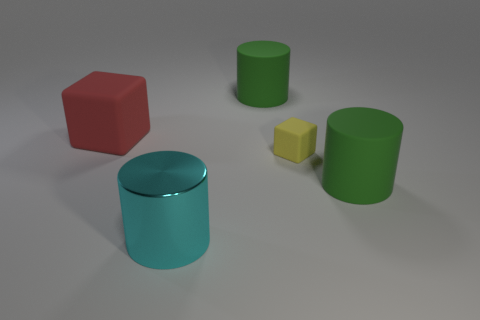Are there any other things that are the same size as the yellow matte thing?
Your answer should be compact. No. Is there any other thing that is the same material as the cyan object?
Give a very brief answer. No. There is a object that is both behind the cyan cylinder and in front of the tiny cube; how big is it?
Your answer should be compact. Large. What is the shape of the green matte thing that is on the right side of the small yellow thing?
Your response must be concise. Cylinder. Is the material of the red cube the same as the large green cylinder that is in front of the red rubber block?
Keep it short and to the point. Yes. Does the large cyan metal object have the same shape as the small yellow object?
Give a very brief answer. No. There is another object that is the same shape as the tiny object; what is it made of?
Provide a succinct answer. Rubber. The big cylinder that is both left of the tiny yellow cube and behind the big cyan metallic cylinder is what color?
Your answer should be very brief. Green. What is the color of the tiny rubber cube?
Make the answer very short. Yellow. Is there a cyan object that has the same shape as the red thing?
Provide a succinct answer. No. 